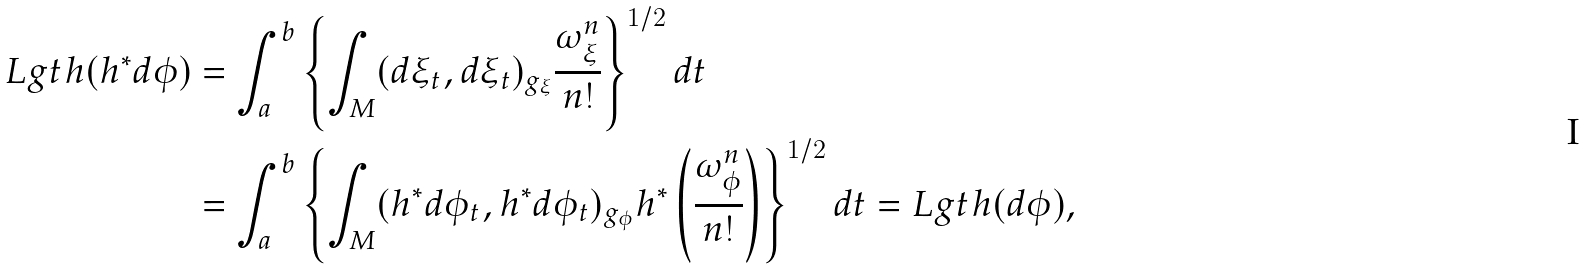<formula> <loc_0><loc_0><loc_500><loc_500>L g t h ( h ^ { * } d \phi ) & = \int _ { a } ^ { b } \left \{ \int _ { M } ( d \xi _ { t } , d \xi _ { t } ) _ { g _ { \xi } } \frac { \omega _ { \xi } ^ { n } } { n ! } \right \} ^ { 1 / 2 } d t \\ & = \int _ { a } ^ { b } \left \{ \int _ { M } ( h ^ { * } d \phi _ { t } , h ^ { * } d \phi _ { t } ) _ { g _ { \phi } } h ^ { * } \left ( \frac { \omega _ { \phi } ^ { n } } { n ! } \right ) \right \} ^ { 1 / 2 } d t = L g t h ( d \phi ) ,</formula> 